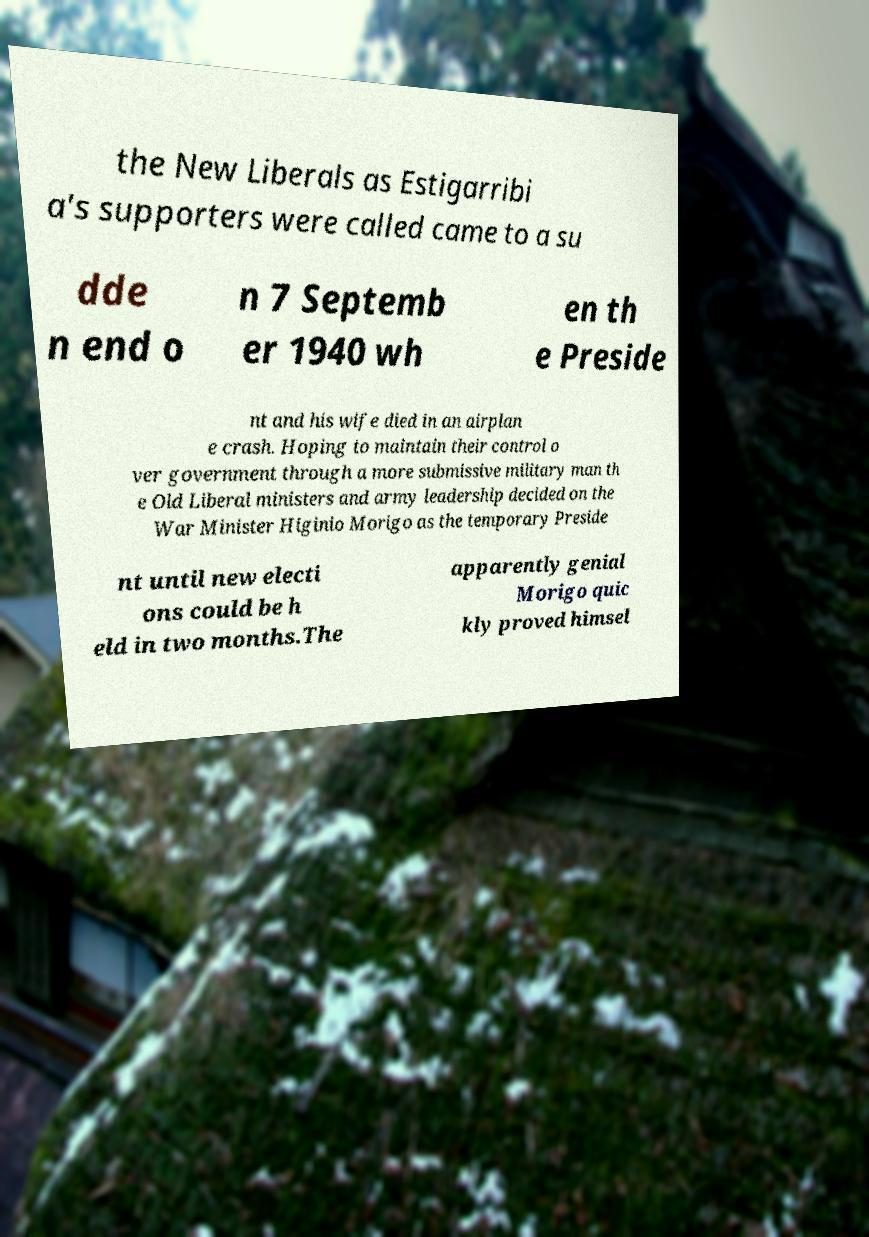Please read and relay the text visible in this image. What does it say? the New Liberals as Estigarribi a's supporters were called came to a su dde n end o n 7 Septemb er 1940 wh en th e Preside nt and his wife died in an airplan e crash. Hoping to maintain their control o ver government through a more submissive military man th e Old Liberal ministers and army leadership decided on the War Minister Higinio Morigo as the temporary Preside nt until new electi ons could be h eld in two months.The apparently genial Morigo quic kly proved himsel 